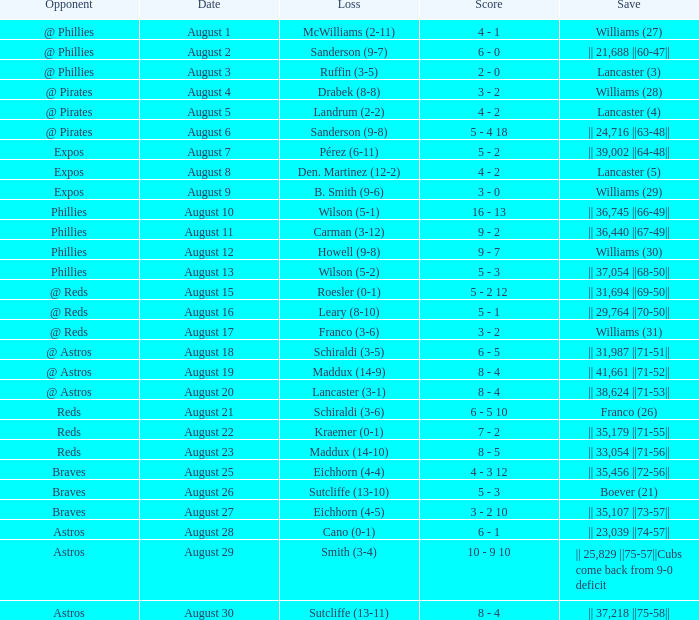Name the opponent with loss of sanderson (9-8) @ Pirates. 